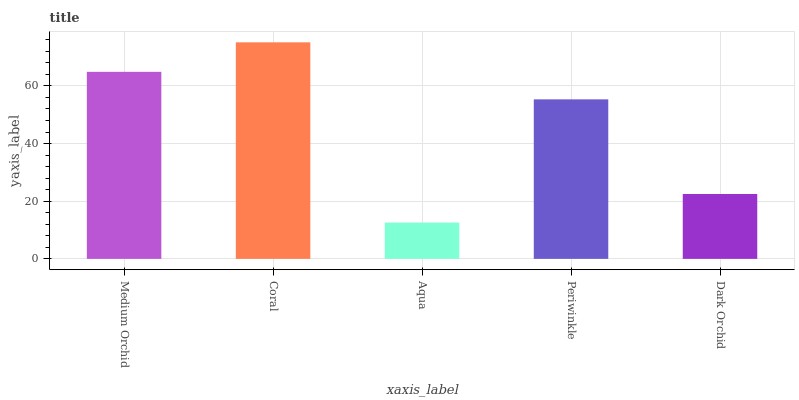Is Aqua the minimum?
Answer yes or no. Yes. Is Coral the maximum?
Answer yes or no. Yes. Is Coral the minimum?
Answer yes or no. No. Is Aqua the maximum?
Answer yes or no. No. Is Coral greater than Aqua?
Answer yes or no. Yes. Is Aqua less than Coral?
Answer yes or no. Yes. Is Aqua greater than Coral?
Answer yes or no. No. Is Coral less than Aqua?
Answer yes or no. No. Is Periwinkle the high median?
Answer yes or no. Yes. Is Periwinkle the low median?
Answer yes or no. Yes. Is Aqua the high median?
Answer yes or no. No. Is Dark Orchid the low median?
Answer yes or no. No. 